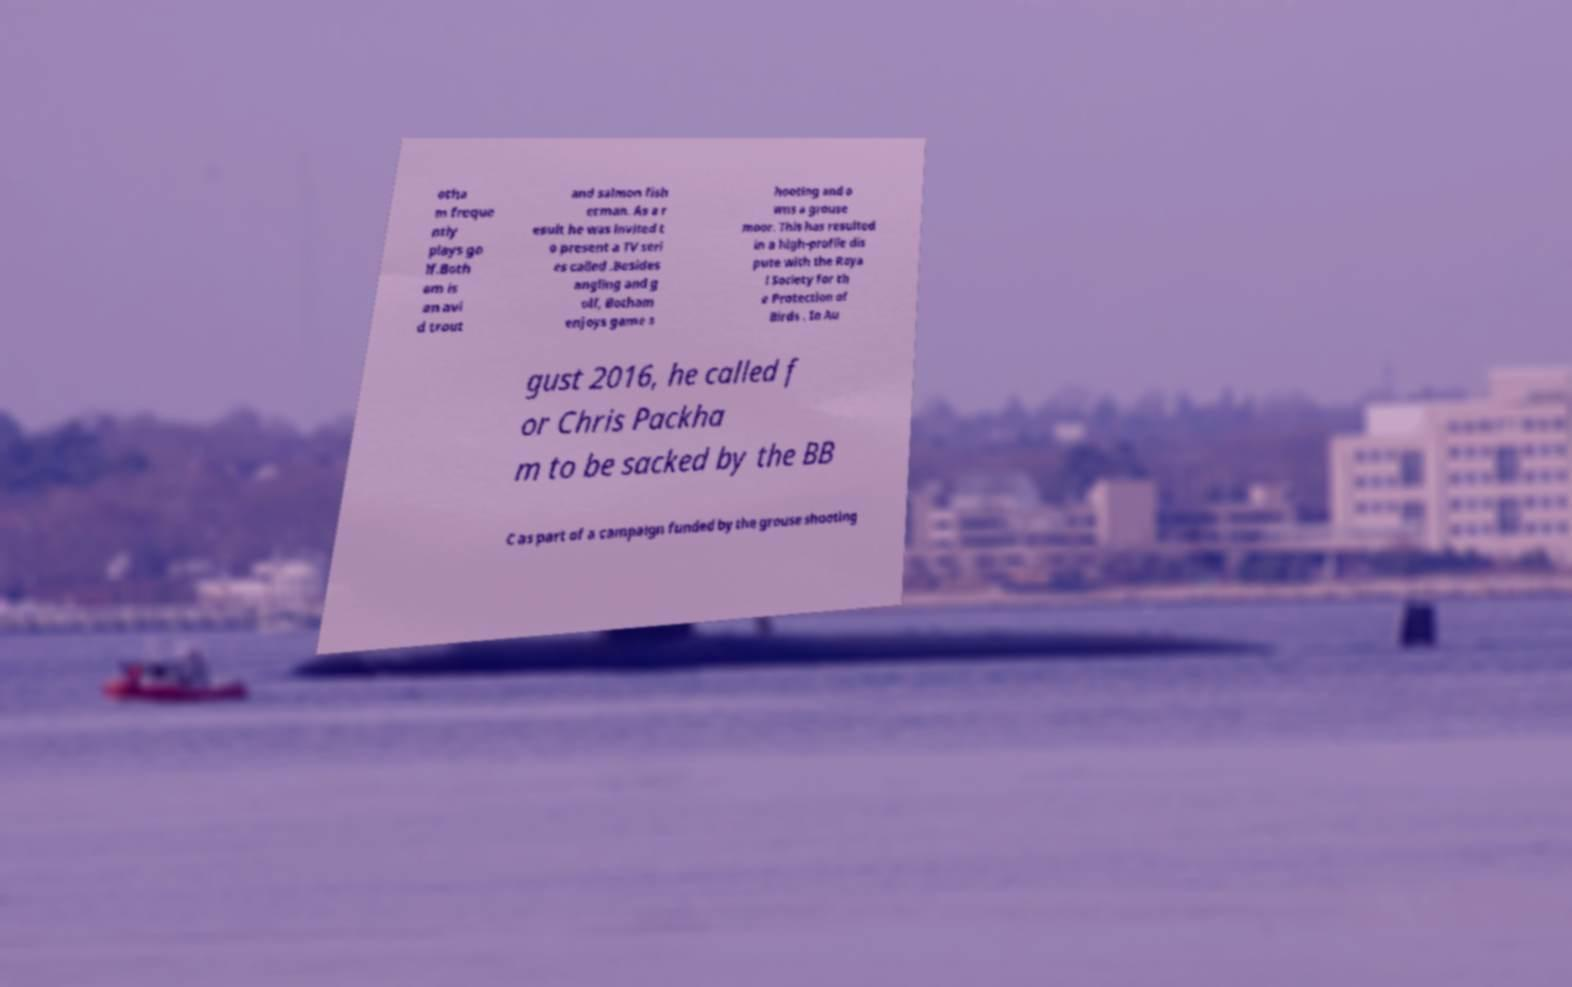Could you assist in decoding the text presented in this image and type it out clearly? otha m freque ntly plays go lf.Both am is an avi d trout and salmon fish erman. As a r esult he was invited t o present a TV seri es called .Besides angling and g olf, Botham enjoys game s hooting and o wns a grouse moor. This has resulted in a high-profile dis pute with the Roya l Society for th e Protection of Birds . In Au gust 2016, he called f or Chris Packha m to be sacked by the BB C as part of a campaign funded by the grouse shooting 